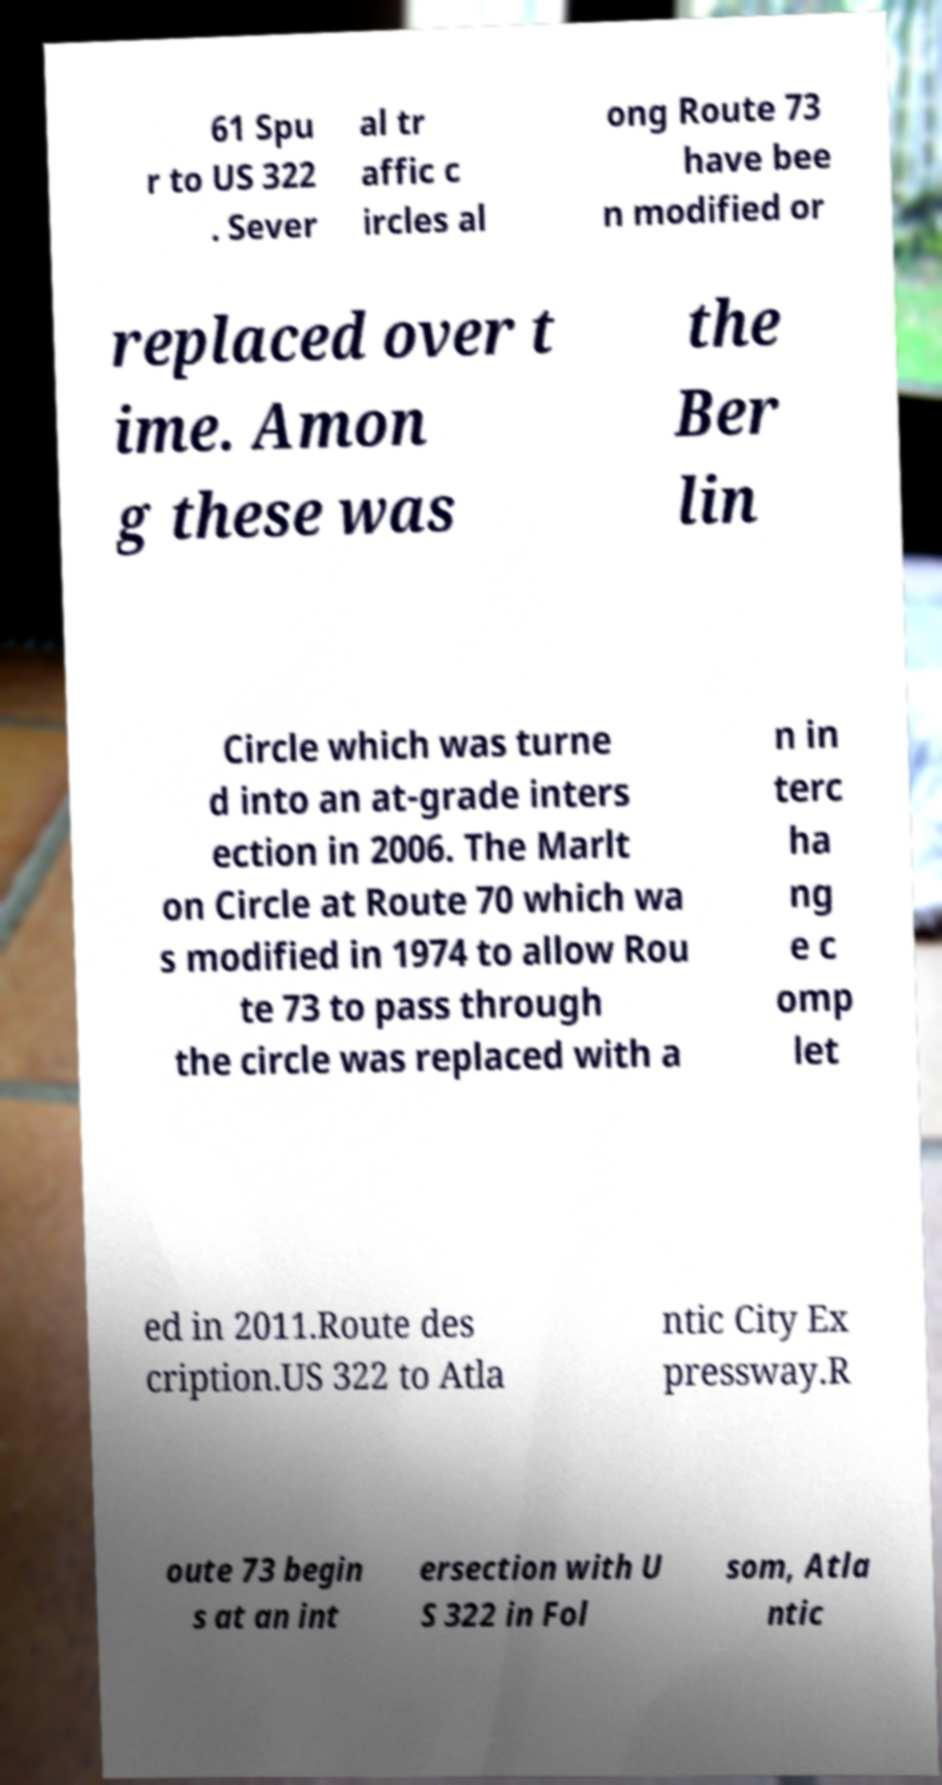Can you accurately transcribe the text from the provided image for me? 61 Spu r to US 322 . Sever al tr affic c ircles al ong Route 73 have bee n modified or replaced over t ime. Amon g these was the Ber lin Circle which was turne d into an at-grade inters ection in 2006. The Marlt on Circle at Route 70 which wa s modified in 1974 to allow Rou te 73 to pass through the circle was replaced with a n in terc ha ng e c omp let ed in 2011.Route des cription.US 322 to Atla ntic City Ex pressway.R oute 73 begin s at an int ersection with U S 322 in Fol som, Atla ntic 